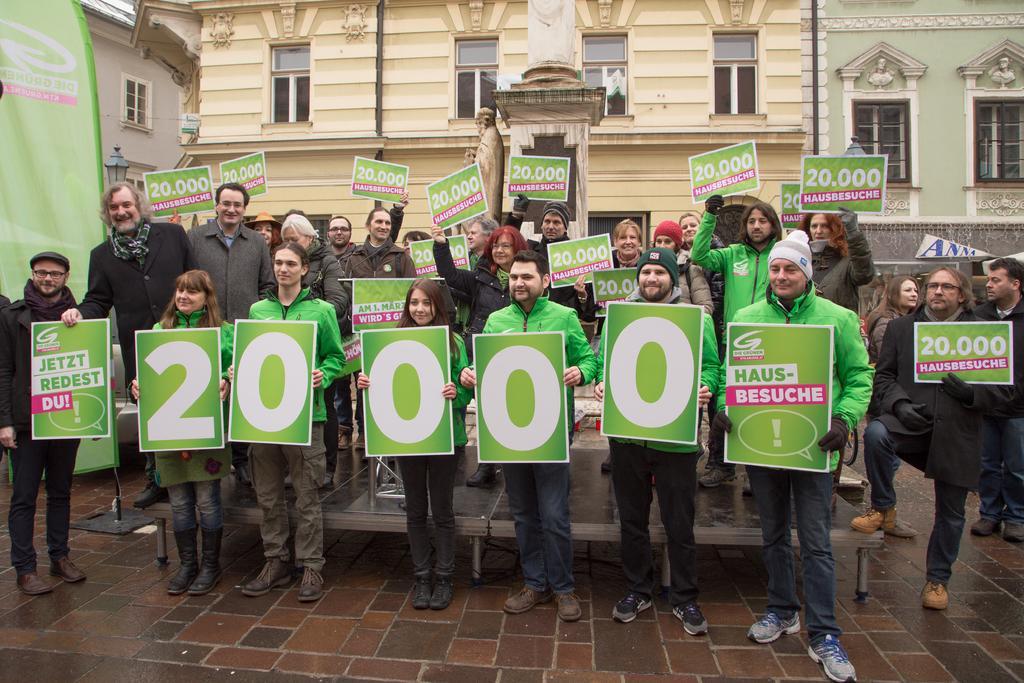Can you describe this image briefly? In this image, we can see some people standing and they are holding some posters, in the background, we can see buildings and there are some windows on the buildings. 